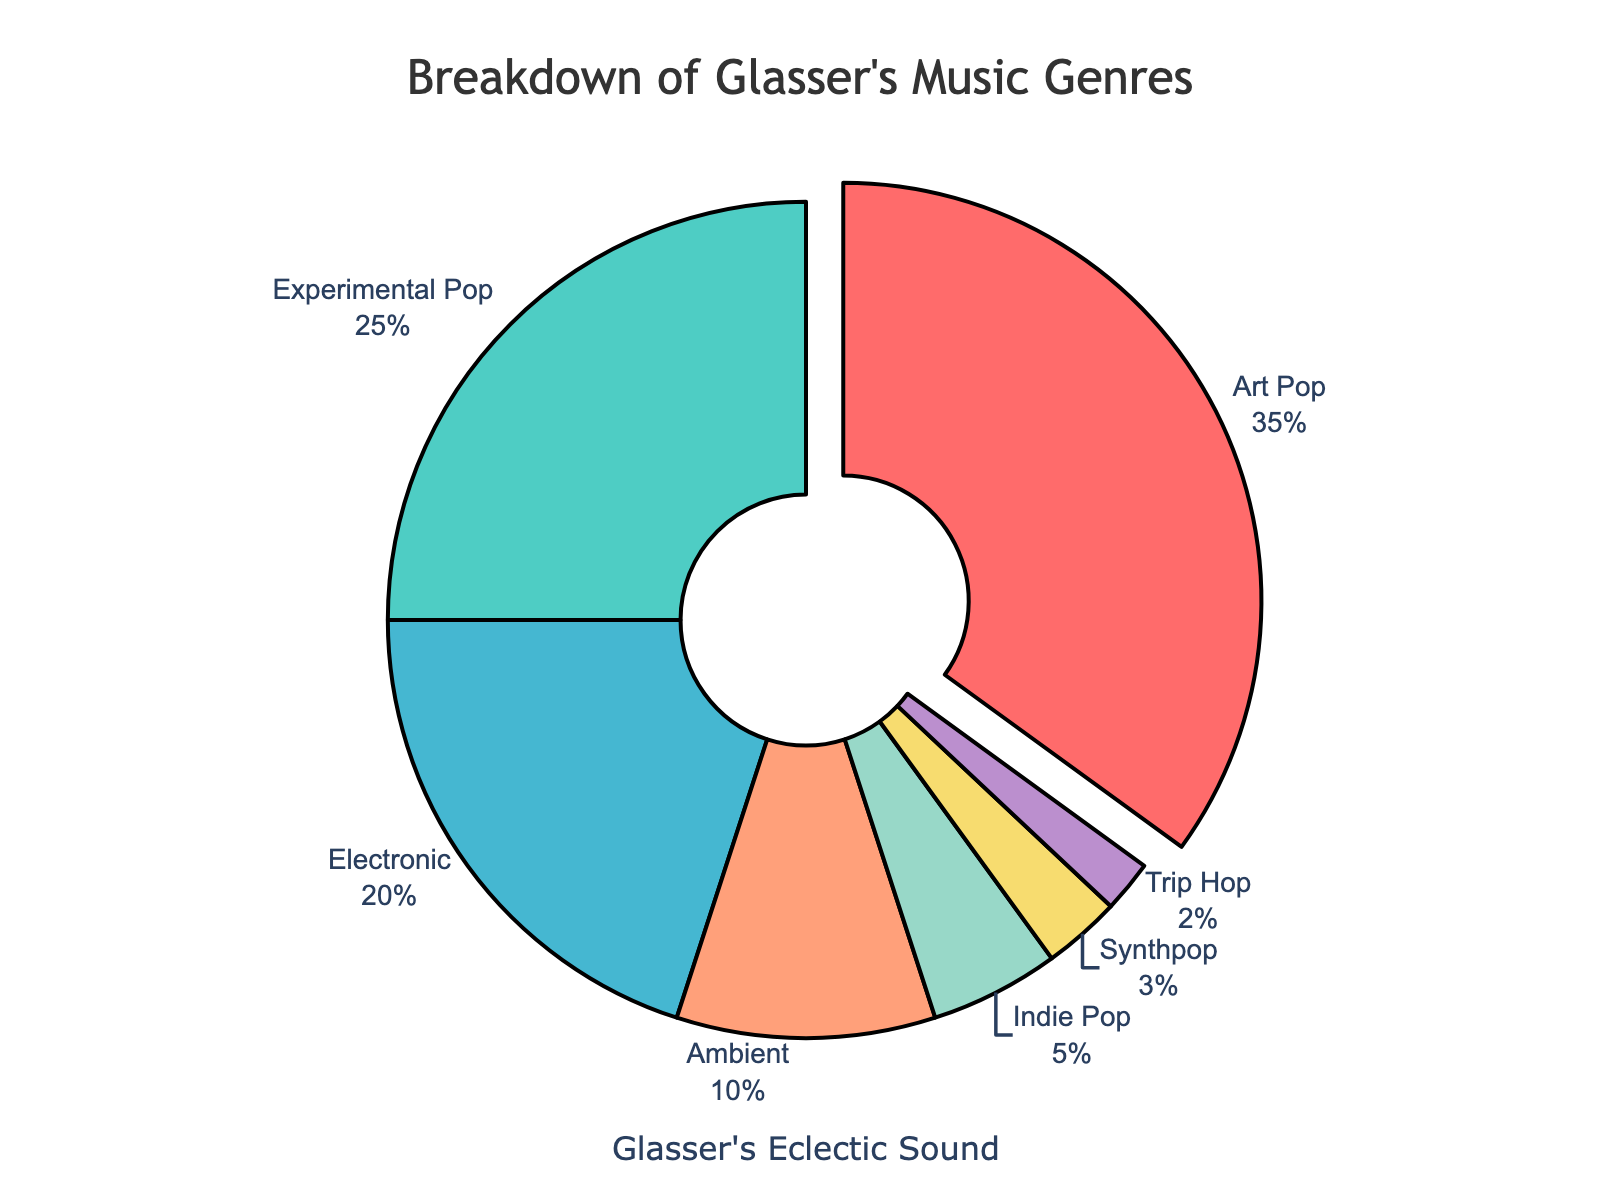Which genre has the largest percentage in Glasser's music? The slice of the pie chart with the largest size represents the genre with the highest percentage. Based on the chart, Art Pop has the largest slice.
Answer: Art Pop Which genre represents only 2% of Glasser's discography? Looking at the pie chart, Trip Hop has a very small slice that is labeled as 2%.
Answer: Trip Hop What is the combined percentage of Electronic and Ambient genres? Adding the percentages of the Electronic (20%) and Ambient (10%) genres gives you the combined percentage. 20% + 10% = 30%.
Answer: 30% Which genre has a smaller percentage of Glasser's music, Indie Pop or Synthpop? The pie chart shows that Indie Pop has a 5% share, while Synthpop has a 3% share. Therefore, Synthpop has a smaller percentage.
Answer: Synthpop How much greater is the percentage of Art Pop compared to Synthpop? Subtract the percentage of Synthpop (3%) from the percentage of Art Pop (35%) to get the difference. 35% - 3% = 32%.
Answer: 32% What is the total percentage of genres that are part of Glasser's experimental side (Experimental Pop + Ambient + Trip Hop)? Add the percentages of Experimental Pop (25%), Ambient (10%), and Trip Hop (2%) to get the total. 25% + 10% + 2% = 37%.
Answer: 37% Which genres have a percentage that is higher than 20%? The pie chart shows that Art Pop has 35% and Experimental Pop has 25%, both higher than 20%.
Answer: Art Pop and Experimental Pop Which genre uses the color red in the pie chart? Art Pop is represented by the color red in the pie chart.
Answer: Art Pop What is the combined percentage of the three least represented genres? Adding the percentages of Indie Pop (5%), Synthpop (3%), and Trip Hop (2%) gives the combined percentage. 5% + 3% + 2% = 10%.
Answer: 10% How does the percentage of Experimental Pop compare to that of Ambient? The pie chart shows Experimental Pop is 25% and Ambient is 10%. Experimental Pop has a higher percentage.
Answer: Experimental Pop has a higher percentage 